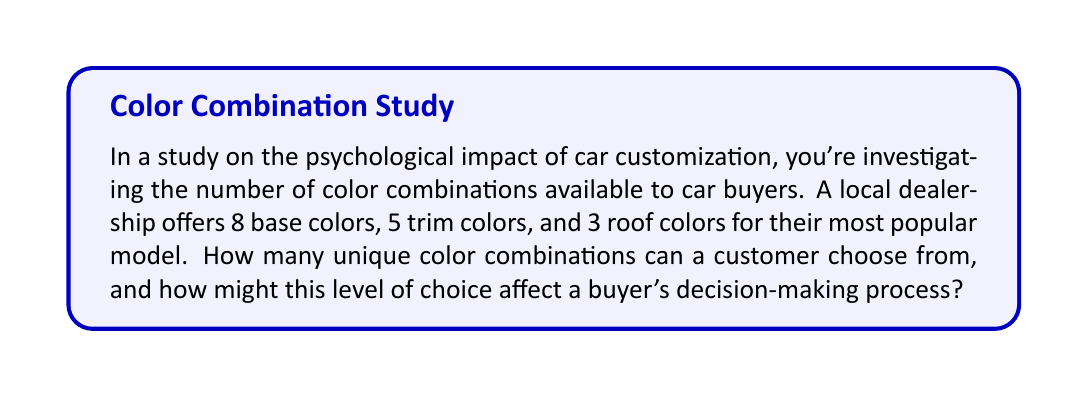What is the answer to this math problem? To solve this problem, we'll use the multiplication principle of counting. This principle states that if we have $m$ ways of doing one thing and $n$ ways of doing another independent thing, then there are $m \times n$ ways to do both things.

Let's break down the problem:

1. Base colors: 8 options
2. Trim colors: 5 options
3. Roof colors: 3 options

Since each choice is independent (the choice of base color doesn't affect the choices for trim or roof color), we multiply these numbers together:

$$ \text{Total combinations} = 8 \times 5 \times 3 $$

$$ = 120 $$

Therefore, there are 120 unique color combinations available to customers.

From a psychological perspective, this number of choices might have interesting effects on buyers:

1. Choice overload: With 120 options, some buyers might feel overwhelmed, leading to decision paralysis or dissatisfaction with their final choice.

2. Perceived control: On the other hand, having many options might give customers a sense of control and personalization, potentially increasing satisfaction with their purchase.

3. Decision-making time: The high number of combinations could lead to longer decision-making processes, which might affect the overall car-buying experience.

4. Post-purchase satisfaction: The ability to highly customize their car might lead to greater post-purchase satisfaction, as buyers feel their car truly reflects their preferences.
Answer: 120 combinations 